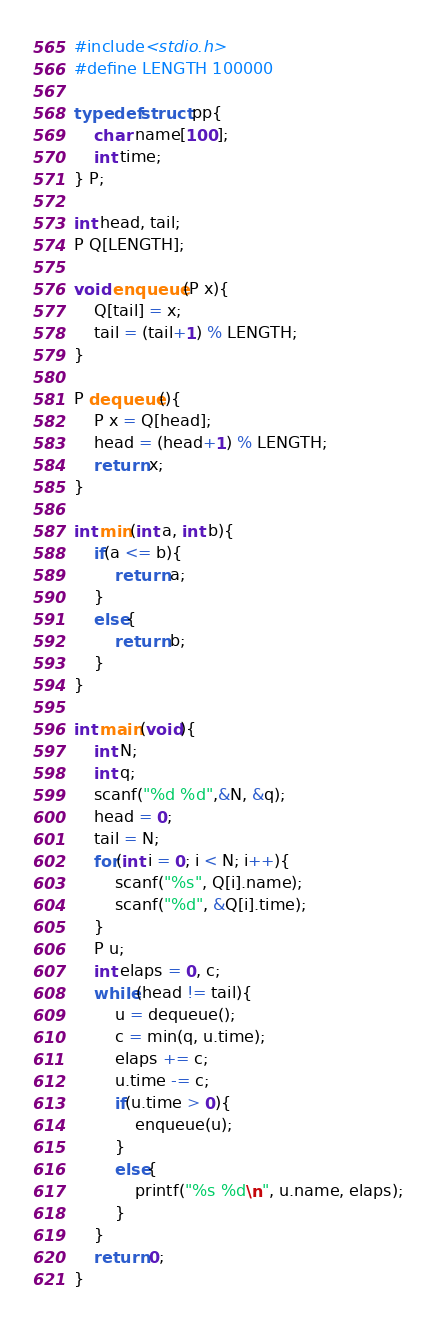<code> <loc_0><loc_0><loc_500><loc_500><_C_>#include<stdio.h>
#define LENGTH 100000

typedef struct pp{
    char name[100];
    int time;
} P;

int head, tail;
P Q[LENGTH];

void enqueue(P x){
    Q[tail] = x;
    tail = (tail+1) % LENGTH;
}

P dequeue(){
    P x = Q[head];
    head = (head+1) % LENGTH;
    return x;
}

int min(int a, int b){
    if(a <= b){
        return a;
    }
    else{
        return b;
    }
}

int main(void){
    int N;
    int q;
    scanf("%d %d",&N, &q);
    head = 0;
    tail = N;
    for(int i = 0; i < N; i++){
        scanf("%s", Q[i].name);
        scanf("%d", &Q[i].time);
    }
    P u;
    int elaps = 0, c;
    while(head != tail){
        u = dequeue();
        c = min(q, u.time);
        elaps += c;
        u.time -= c;
        if(u.time > 0){
            enqueue(u);
        }
        else{
            printf("%s %d\n", u.name, elaps);
        }
    }
    return 0;
}
</code> 